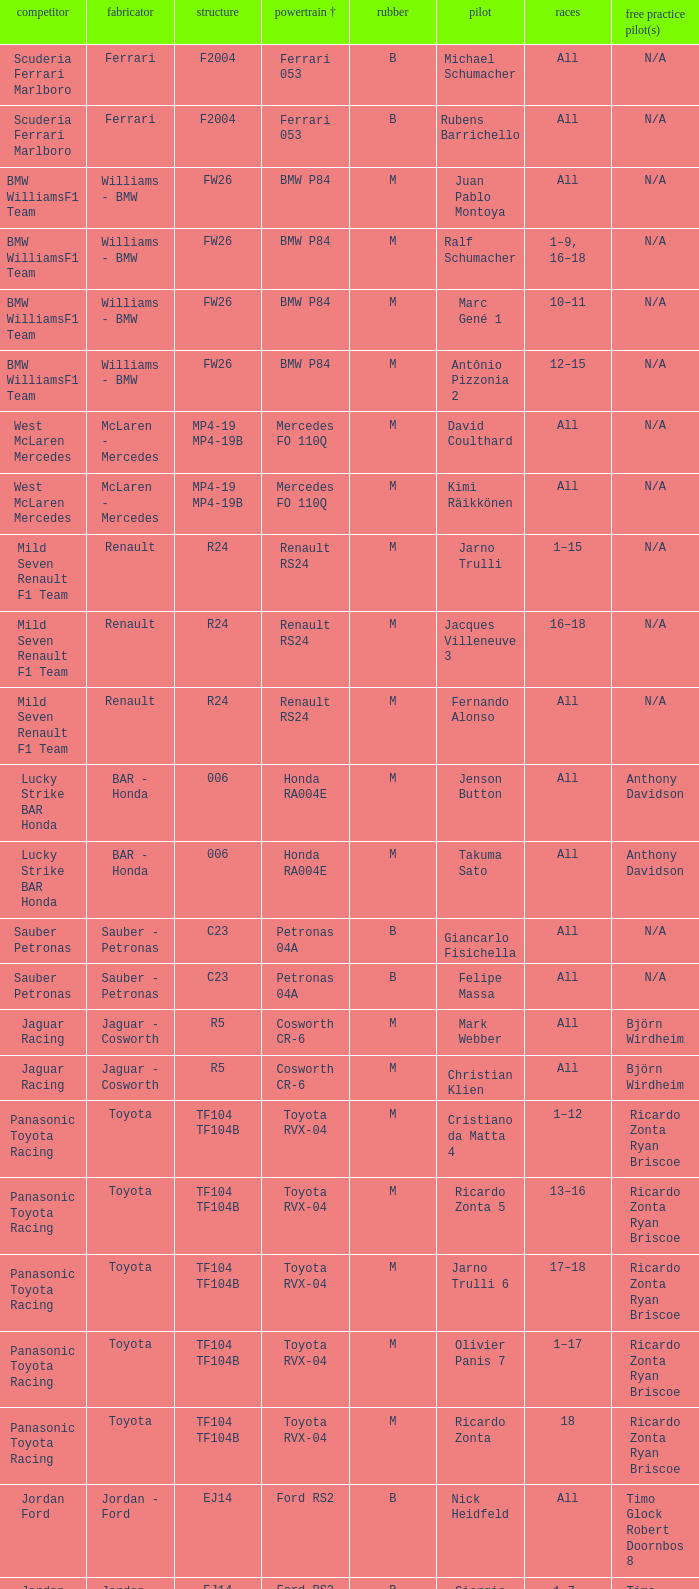What kind of free practice is there with a Ford RS2 engine +? Timo Glock Robert Doornbos 8, Timo Glock Robert Doornbos 8, Timo Glock Robert Doornbos 8. 